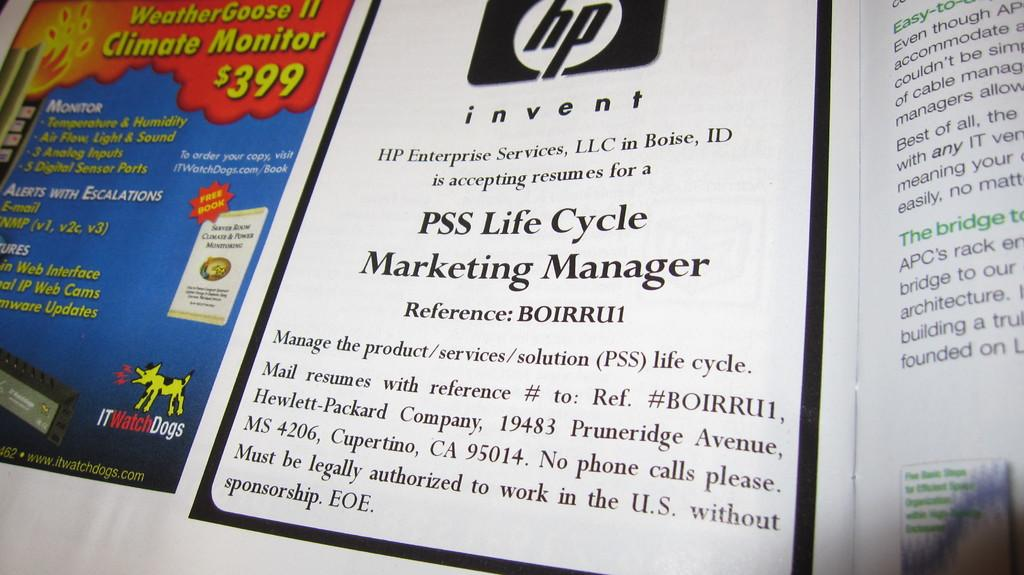Provide a one-sentence caption for the provided image. A magazine includes an ad for the Weather Goose II monitor. 